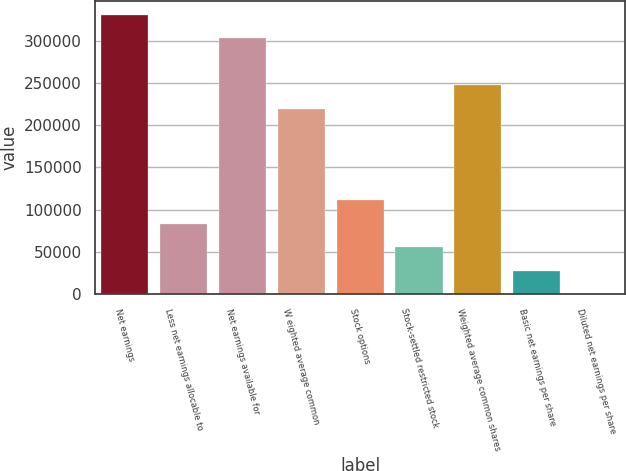<chart> <loc_0><loc_0><loc_500><loc_500><bar_chart><fcel>Net earnings<fcel>Less net earnings allocable to<fcel>Net earnings available for<fcel>W eighted average common<fcel>Stock options<fcel>Stock-settled restricted stock<fcel>Weighted average common shares<fcel>Basic net earnings per share<fcel>Diluted net earnings per share<nl><fcel>331069<fcel>83354.1<fcel>303284<fcel>219527<fcel>111138<fcel>55569.8<fcel>247311<fcel>27785.5<fcel>1.24<nl></chart> 